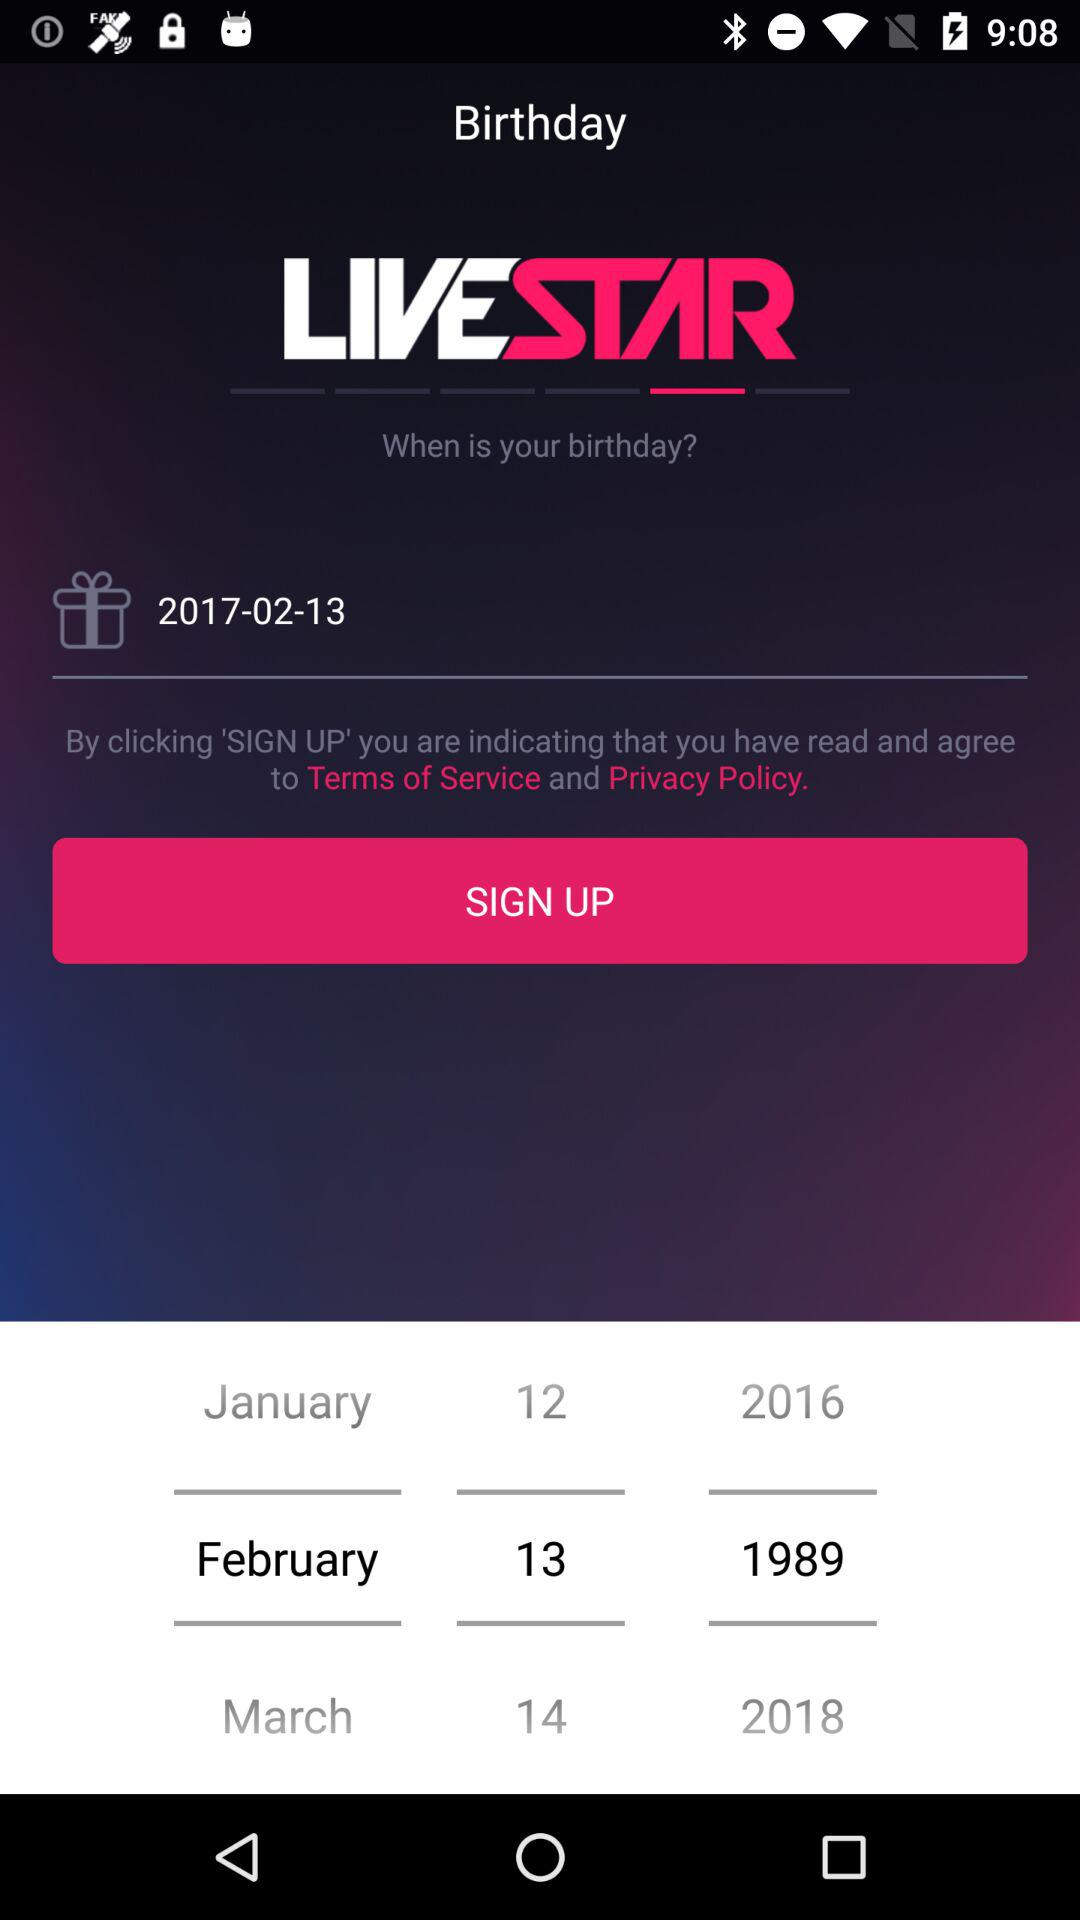What is the birthday date? The date is February 13, 2017. 